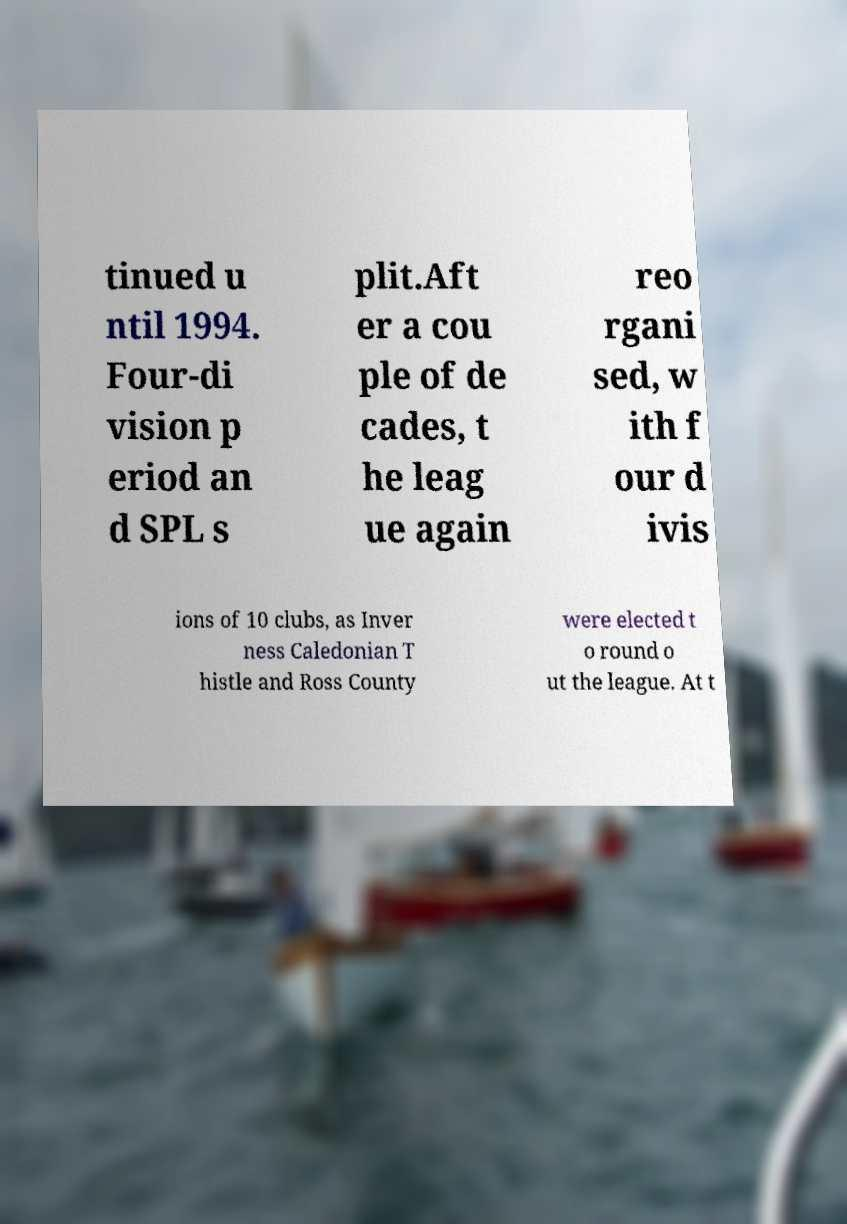Can you accurately transcribe the text from the provided image for me? tinued u ntil 1994. Four-di vision p eriod an d SPL s plit.Aft er a cou ple of de cades, t he leag ue again reo rgani sed, w ith f our d ivis ions of 10 clubs, as Inver ness Caledonian T histle and Ross County were elected t o round o ut the league. At t 